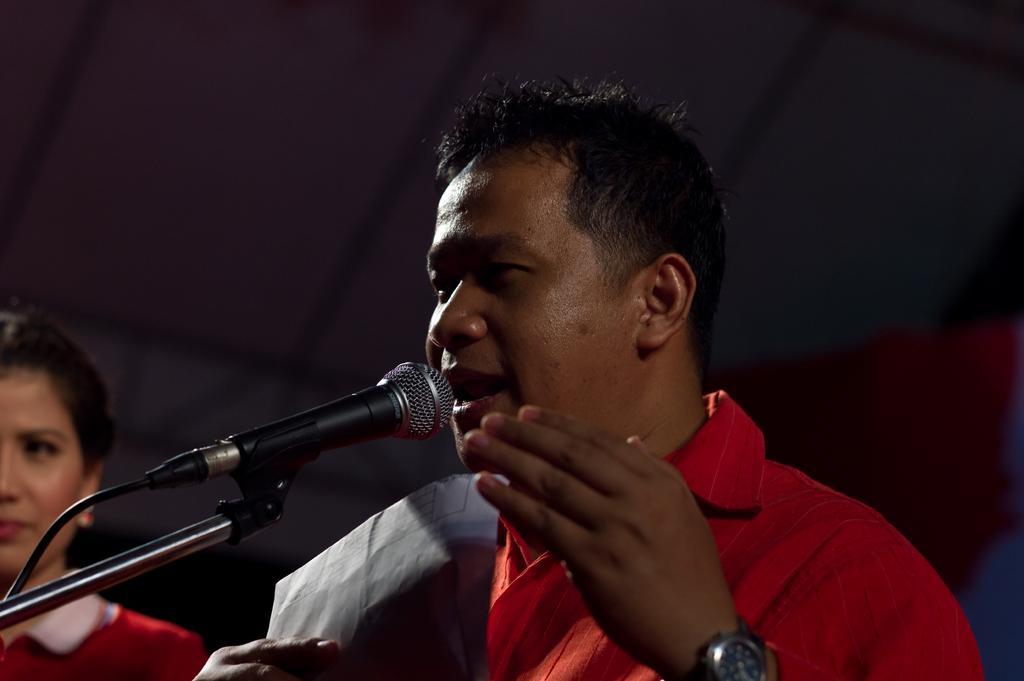In one or two sentences, can you explain what this image depicts? In the center of the image we can see a man holding a paper, before him there is a mic placed on the stand. On the left there is a lady. 